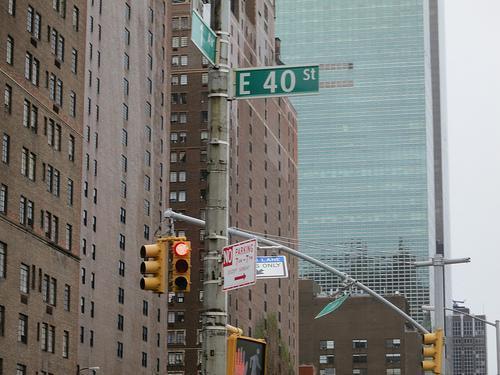How many no parking signs are shown?
Give a very brief answer. 1. 